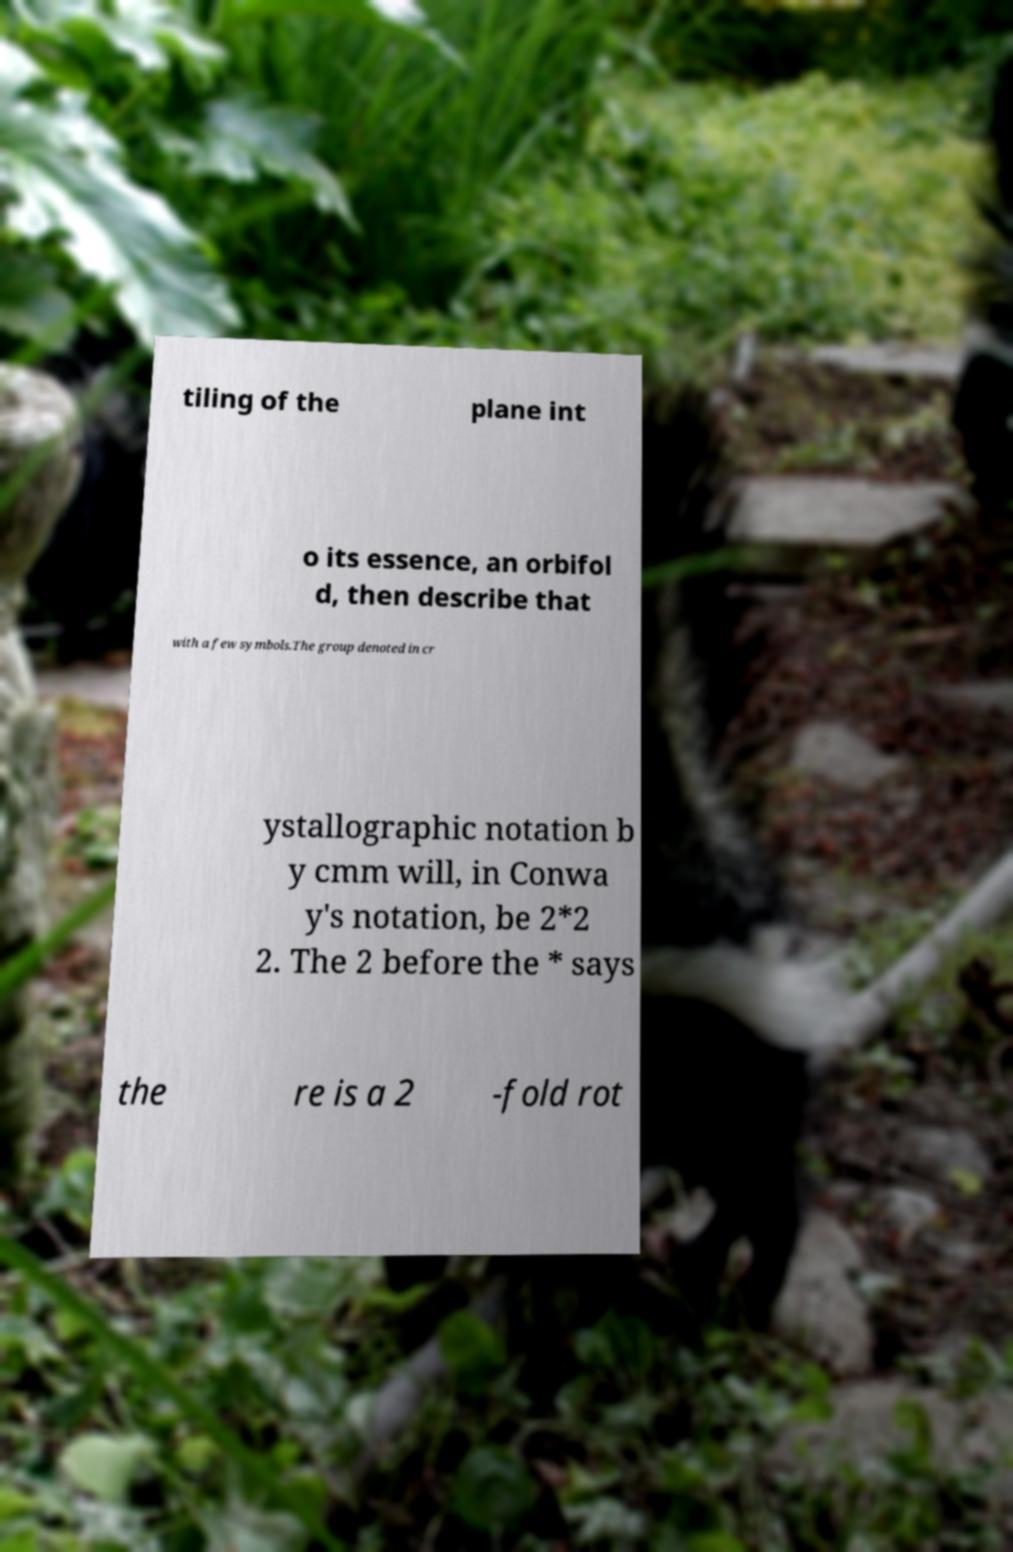What messages or text are displayed in this image? I need them in a readable, typed format. tiling of the plane int o its essence, an orbifol d, then describe that with a few symbols.The group denoted in cr ystallographic notation b y cmm will, in Conwa y's notation, be 2*2 2. The 2 before the * says the re is a 2 -fold rot 